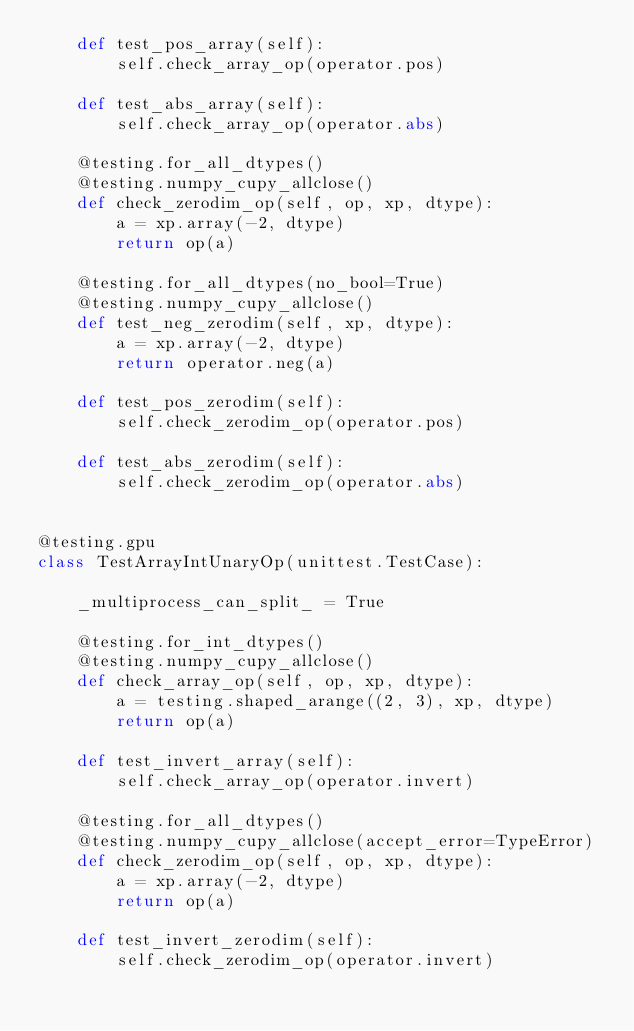Convert code to text. <code><loc_0><loc_0><loc_500><loc_500><_Python_>    def test_pos_array(self):
        self.check_array_op(operator.pos)

    def test_abs_array(self):
        self.check_array_op(operator.abs)

    @testing.for_all_dtypes()
    @testing.numpy_cupy_allclose()
    def check_zerodim_op(self, op, xp, dtype):
        a = xp.array(-2, dtype)
        return op(a)

    @testing.for_all_dtypes(no_bool=True)
    @testing.numpy_cupy_allclose()
    def test_neg_zerodim(self, xp, dtype):
        a = xp.array(-2, dtype)
        return operator.neg(a)

    def test_pos_zerodim(self):
        self.check_zerodim_op(operator.pos)

    def test_abs_zerodim(self):
        self.check_zerodim_op(operator.abs)


@testing.gpu
class TestArrayIntUnaryOp(unittest.TestCase):

    _multiprocess_can_split_ = True

    @testing.for_int_dtypes()
    @testing.numpy_cupy_allclose()
    def check_array_op(self, op, xp, dtype):
        a = testing.shaped_arange((2, 3), xp, dtype)
        return op(a)

    def test_invert_array(self):
        self.check_array_op(operator.invert)

    @testing.for_all_dtypes()
    @testing.numpy_cupy_allclose(accept_error=TypeError)
    def check_zerodim_op(self, op, xp, dtype):
        a = xp.array(-2, dtype)
        return op(a)

    def test_invert_zerodim(self):
        self.check_zerodim_op(operator.invert)
</code> 